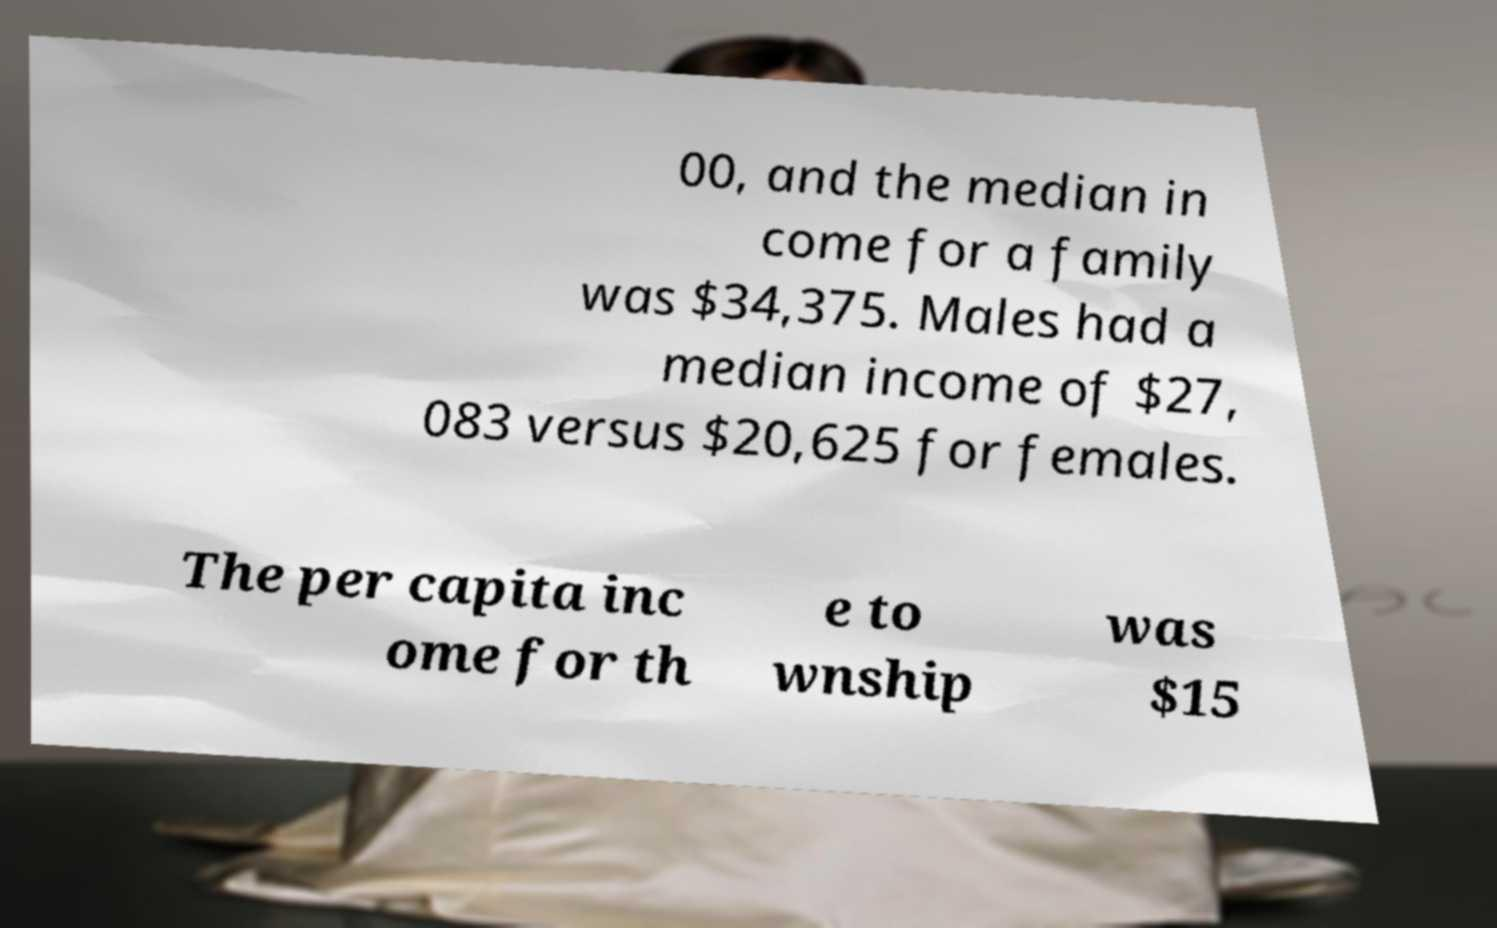I need the written content from this picture converted into text. Can you do that? 00, and the median in come for a family was $34,375. Males had a median income of $27, 083 versus $20,625 for females. The per capita inc ome for th e to wnship was $15 